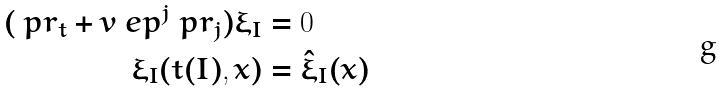Convert formula to latex. <formula><loc_0><loc_0><loc_500><loc_500>( \ p r _ { t } + v _ { \ } e p ^ { j } \ p r _ { j } ) \xi _ { I } & = 0 \\ \xi _ { I } ( t ( I ) , x ) & = { \hat { \xi } } _ { I } ( x )</formula> 